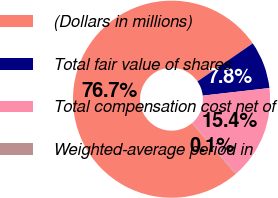Convert chart to OTSL. <chart><loc_0><loc_0><loc_500><loc_500><pie_chart><fcel>(Dollars in millions)<fcel>Total fair value of shares<fcel>Total compensation cost net of<fcel>Weighted-average period in<nl><fcel>76.69%<fcel>7.77%<fcel>15.43%<fcel>0.11%<nl></chart> 